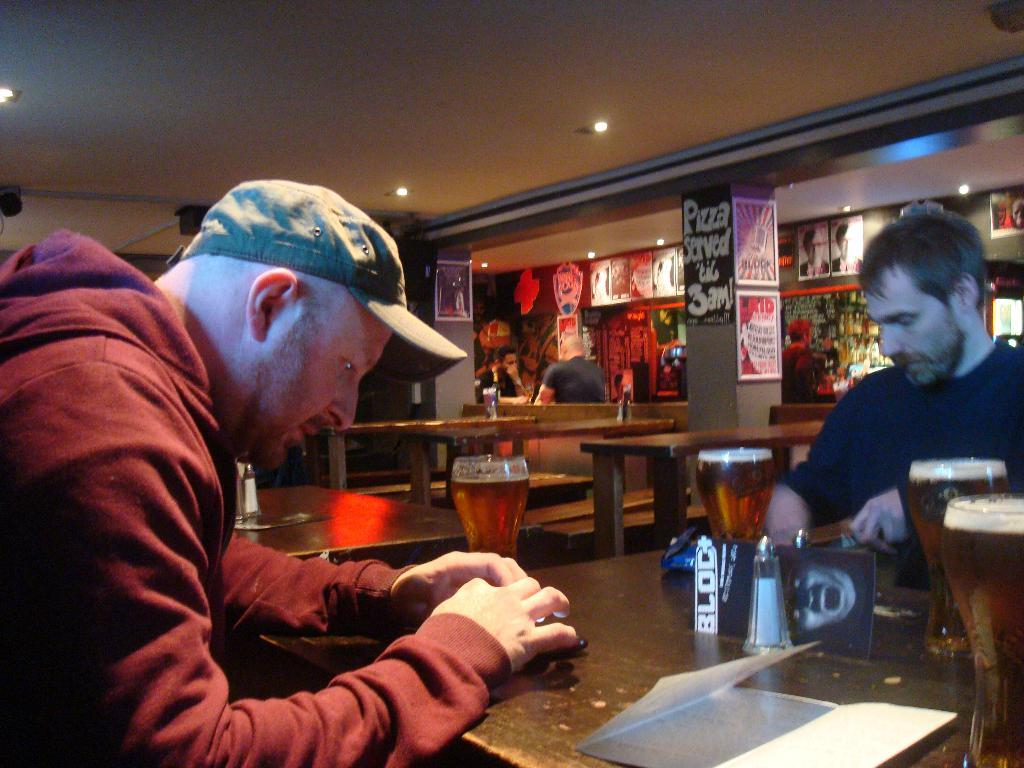How many men are sitting in the image? There are two men sitting in the image. What objects are on the table in the image? There are two glasses on a table in the image. What can be seen in the background of the image? There are people and tables in the background of the image. What type of knot is being tied by the men in the image? There is no knot being tied by the men in the image; they are simply sitting. 